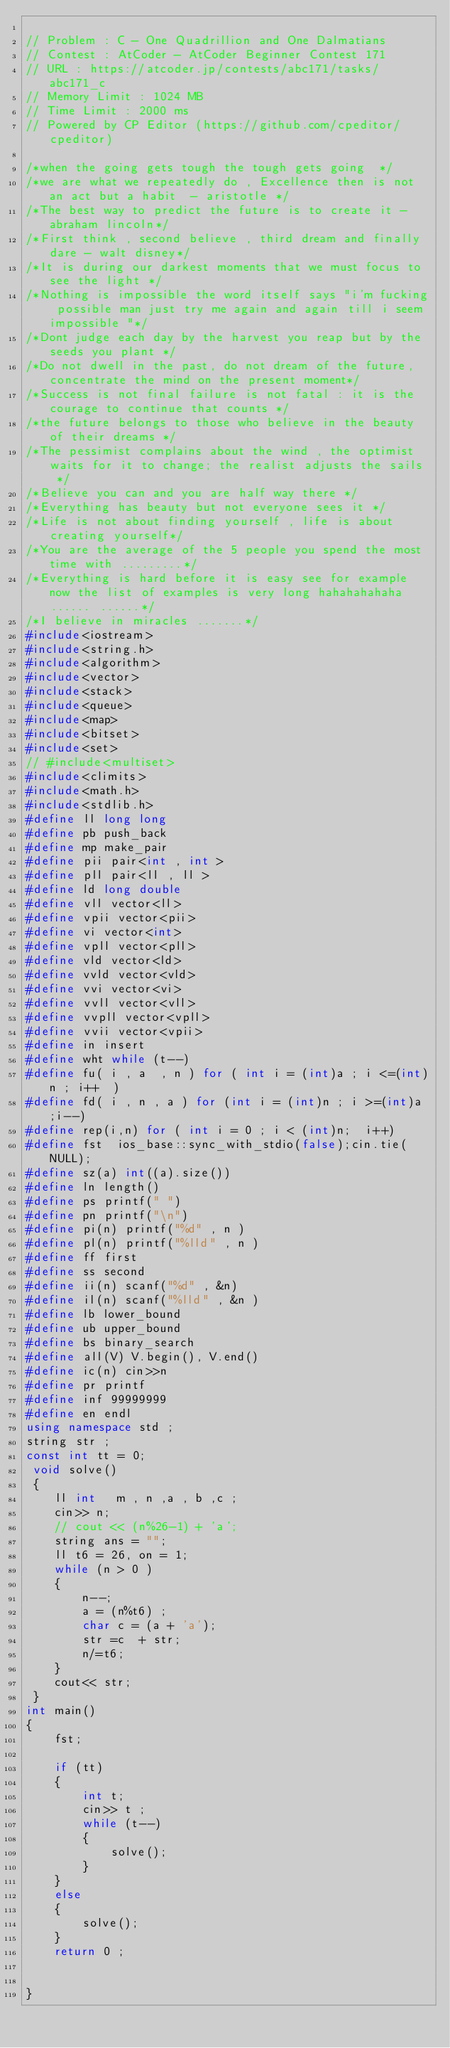<code> <loc_0><loc_0><loc_500><loc_500><_C++_>
// Problem : C - One Quadrillion and One Dalmatians
// Contest : AtCoder - AtCoder Beginner Contest 171
// URL : https://atcoder.jp/contests/abc171/tasks/abc171_c
// Memory Limit : 1024 MB
// Time Limit : 2000 ms
// Powered by CP Editor (https://github.com/cpeditor/cpeditor)

/*when the going gets tough the tough gets going  */
/*we are what we repeatedly do , Excellence then is not an act but a habit  - aristotle */
/*The best way to predict the future is to create it - abraham lincoln*/
/*First think , second believe , third dream and finally dare - walt disney*/
/*It is during our darkest moments that we must focus to see the light */
/*Nothing is impossible the word itself says "i'm fucking possible man just try me again and again till i seem impossible "*/
/*Dont judge each day by the harvest you reap but by the seeds you plant */
/*Do not dwell in the past, do not dream of the future, concentrate the mind on the present moment*/
/*Success is not final failure is not fatal : it is the courage to continue that counts */ 
/*the future belongs to those who believe in the beauty of their dreams */
/*The pessimist complains about the wind , the optimist waits for it to change; the realist adjusts the sails  */
/*Believe you can and you are half way there */
/*Everything has beauty but not everyone sees it */
/*Life is not about finding yourself , life is about creating yourself*/
/*You are the average of the 5 people you spend the most time with .........*/
/*Everything is hard before it is easy see for example now the list of examples is very long hahahahahaha...... ......*/
/*I believe in miracles .......*/
#include<iostream>
#include<string.h>
#include<algorithm>
#include<vector>
#include<stack>
#include<queue>
#include<map>
#include<bitset>
#include<set>
// #include<multiset>
#include<climits>
#include<math.h>
#include<stdlib.h>
#define ll long long 
#define pb push_back
#define mp make_pair
#define pii pair<int , int > 
#define pll pair<ll , ll >
#define ld long double
#define vll vector<ll>
#define vpii vector<pii>
#define vi vector<int>
#define vpll vector<pll>
#define vld vector<ld>
#define vvld vector<vld>
#define vvi vector<vi>
#define vvll vector<vll>
#define vvpll vector<vpll>
#define vvii vector<vpii>
#define in insert
#define wht while (t--)
#define fu( i , a  , n ) for ( int i = (int)a ; i <=(int)n ; i++  )
#define fd( i , n , a ) for (int i = (int)n ; i >=(int)a ;i--)
#define rep(i,n) for ( int i = 0 ; i < (int)n;  i++)
#define fst  ios_base::sync_with_stdio(false);cin.tie(NULL);
#define sz(a) int((a).size())
#define ln length()
#define ps printf(" ") 
#define pn printf("\n")
#define pi(n) printf("%d" , n ) 
#define pl(n) printf("%lld" , n )
#define ff first
#define ss second
#define ii(n) scanf("%d" , &n)
#define il(n) scanf("%lld" , &n )
#define lb lower_bound
#define ub upper_bound
#define bs binary_search
#define all(V) V.begin(), V.end()
#define ic(n) cin>>n
#define pr printf
#define inf 99999999
#define en endl
using namespace std ;
string str ;
const int tt = 0;
 void solve()
 {
 	ll int   m , n ,a , b ,c ;
 	cin>> n;
 	// cout << (n%26-1) + 'a';
 	string ans = "";
 	ll t6 = 26, on = 1;
 	while (n > 0 )
 	{
 		n--;
 		a = (n%t6) ;
 		char c = (a + 'a');
 		str =c  + str;
 		n/=t6;
 	}
 	cout<< str;
 }
int main()
{
	fst;
	
    if (tt)
    {
    	int t;
    	cin>> t ;
    	while (t--)
    	{
    		solve();
    	}
    }
    else
    {
    	solve();
    }
	return 0 ;
	
 
} </code> 